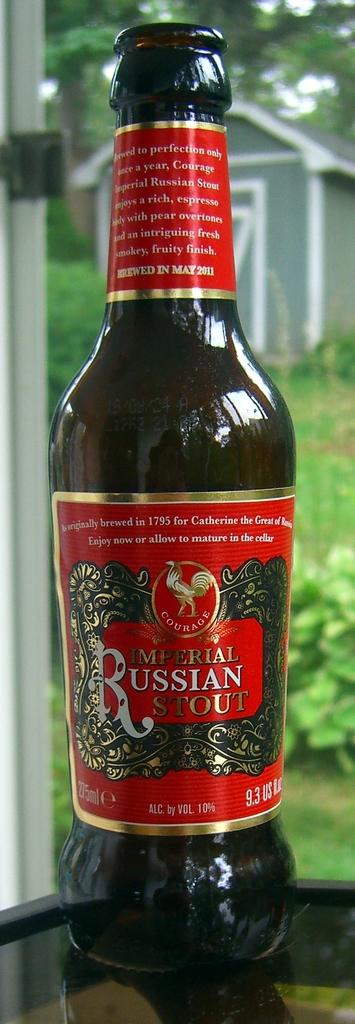In what year did the brewery begin?
Your response must be concise. 1795. 